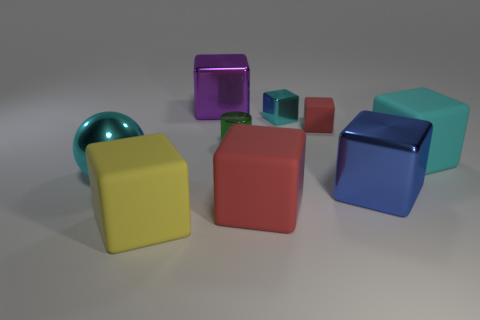Does the lighting affect the appearance of the objects? Yes, the lighting is soft and diffused, creating gentle shadows and subtle highlights that give the objects a three-dimensional appearance. The lighting emphasizes the objects' shapes and textures. Could you describe the texture visible on these objects? The objects exhibit a smooth, matte texture that slightly reflects the light, suggesting they are made of a material like painted metal. 